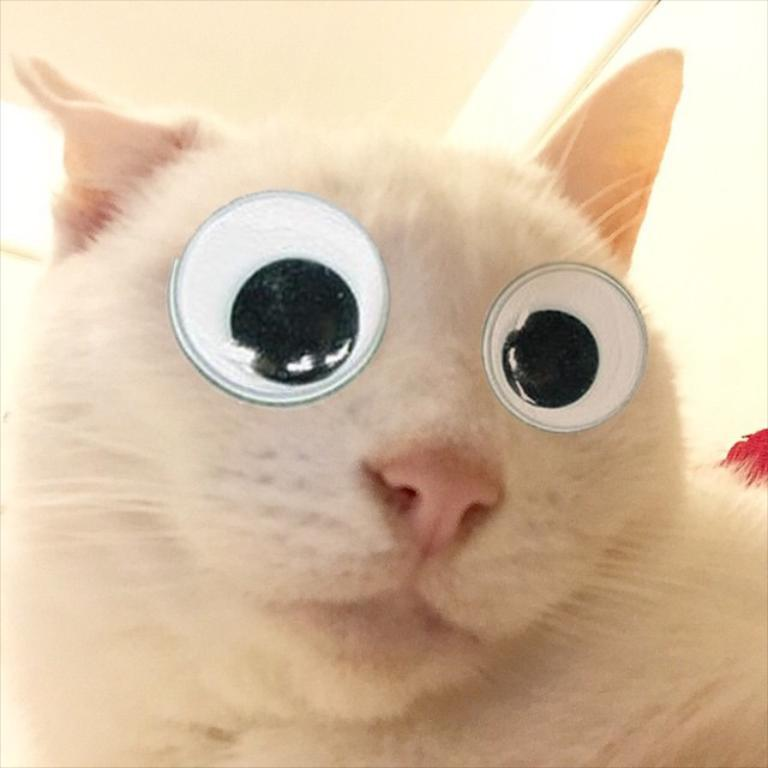Where is the hose connected to in the image? There is no hose present in the image. What type of street is visible in the image? There is no street present in the image. Reasoning: Let's think step by step in order to create an absurd question. We start by acknowledging that no specific facts about the image were provided. Then, we choose one of the provided topics, which in this case is "street." Finally, we formulate an absurd question that asks about the presence of a street in the image, even though no such information was given. This question is designed to be unexpected and unrelated to the actual content of the image. 